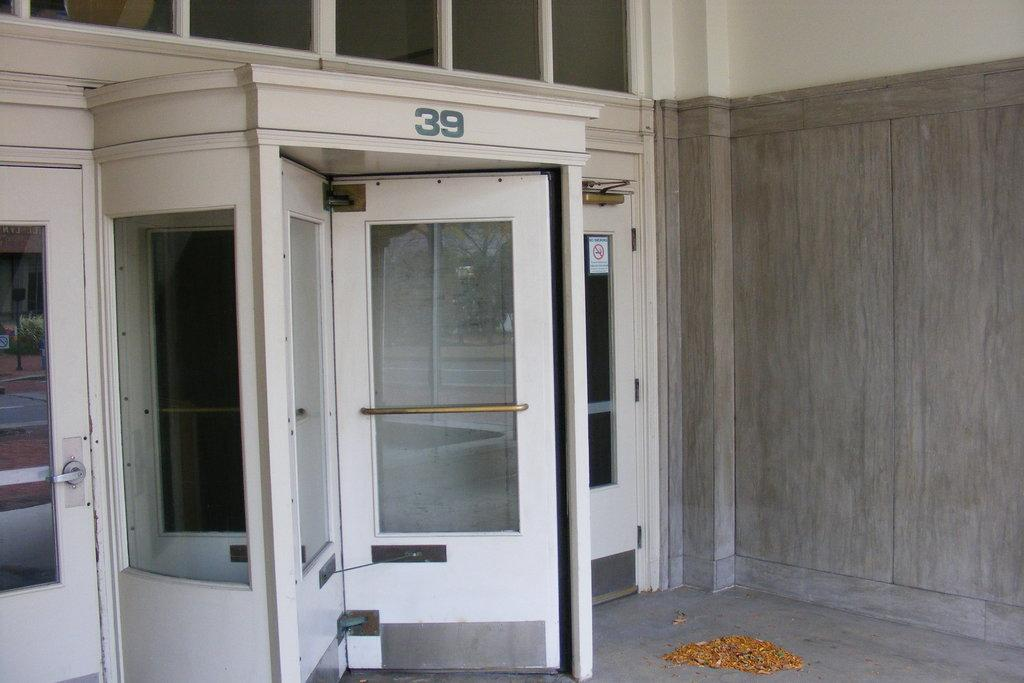<image>
Relay a brief, clear account of the picture shown. a spinning door underneath the number 39 on the outside of a building 